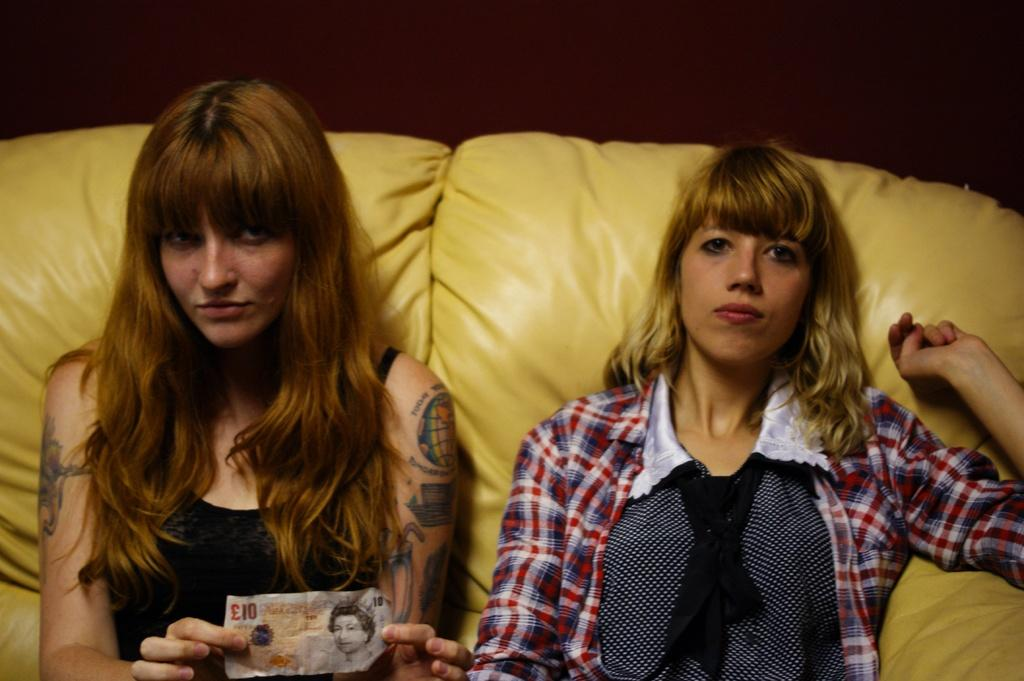Who is present in the image? There are women in the image. What are the women doing in the image? The women are sitting on a sofa. Can you describe the sofa in the image? The sofa is yellow in color. What is one of the women holding in her hands? One of the women is holding a currency note in her hands. Where is the currency note located in the image? The currency note is on the left side of the image. What type of sponge is being used by the women in the image? There is no sponge present in the image. How many heads are visible in the image? The image only shows women sitting on a sofa, and their heads are not visible in the image. 